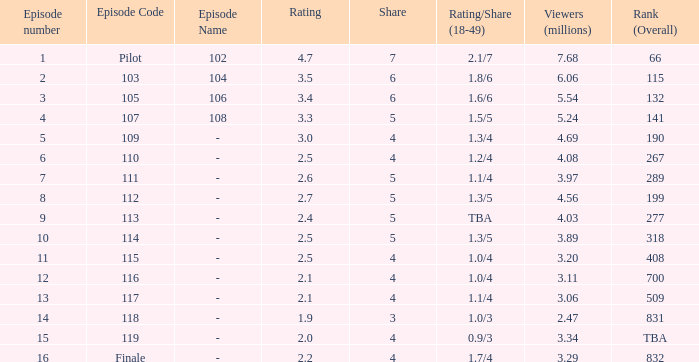WHAT IS THE HIGHEST VIEWERS WITH AN EPISODE LESS THAN 15 AND SHARE LAGER THAN 7? None. 